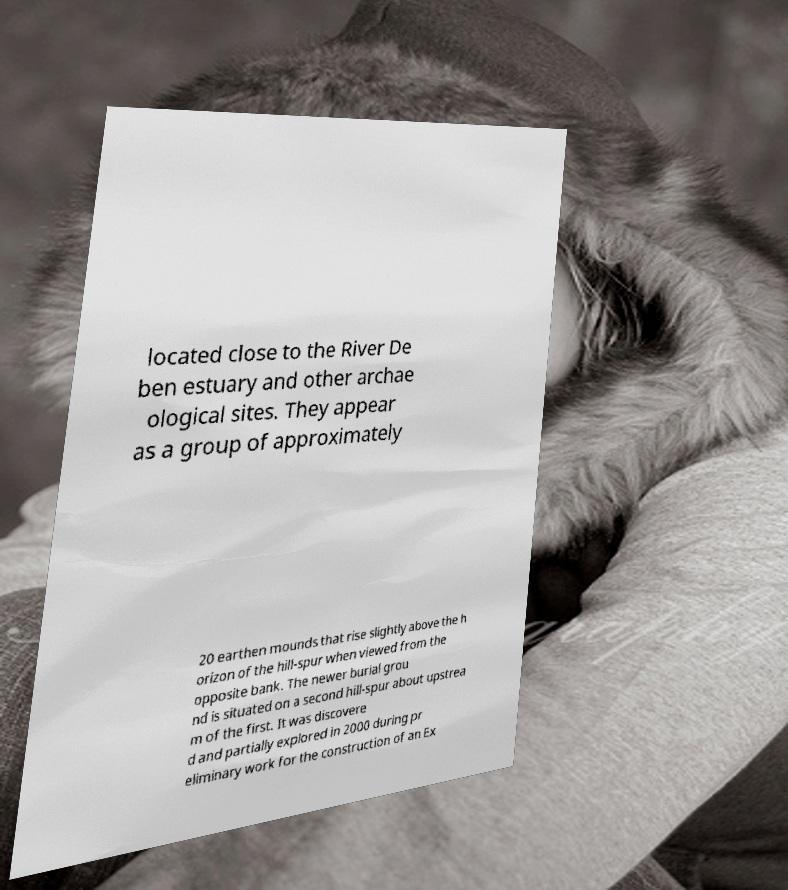Please identify and transcribe the text found in this image. located close to the River De ben estuary and other archae ological sites. They appear as a group of approximately 20 earthen mounds that rise slightly above the h orizon of the hill-spur when viewed from the opposite bank. The newer burial grou nd is situated on a second hill-spur about upstrea m of the first. It was discovere d and partially explored in 2000 during pr eliminary work for the construction of an Ex 